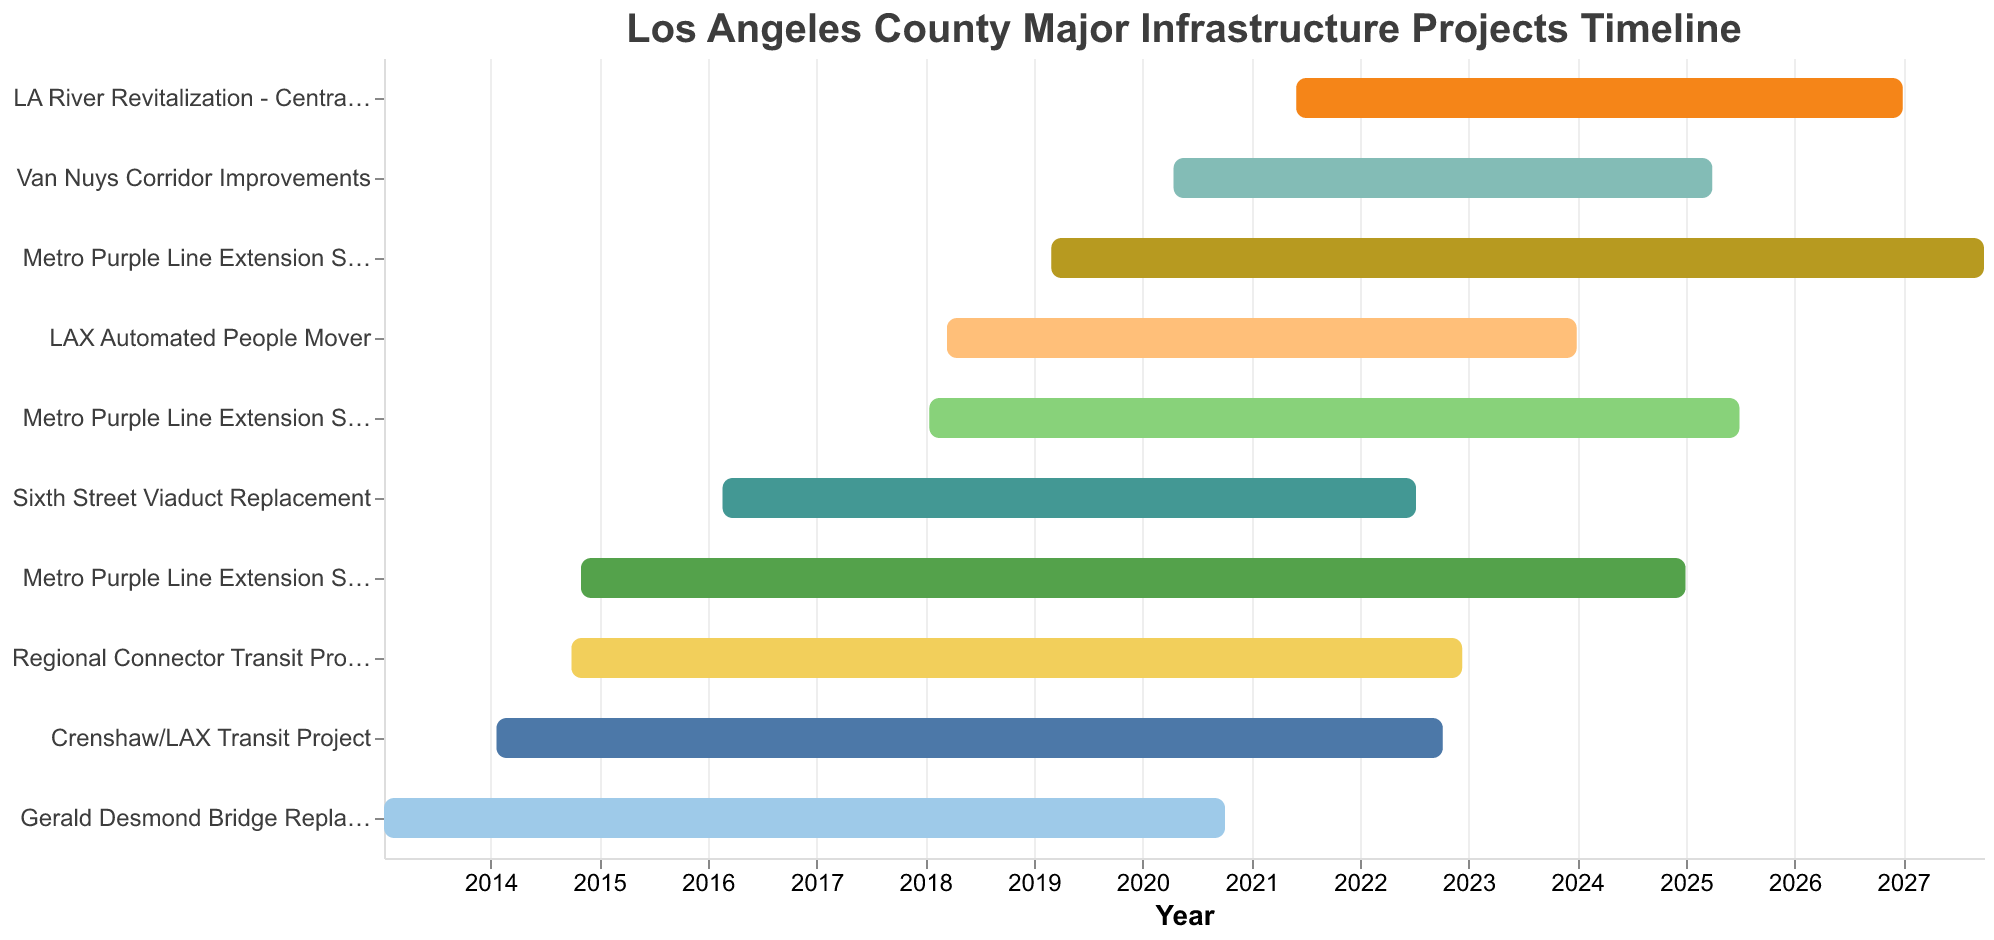What is the title of the figure? The title can be found at the top of the figure in a larger and more prominent font compared to other text elements.
Answer: Los Angeles County Major Infrastructure Projects Timeline Which project has the earliest start date? Examine the leftmost point on the horizontal axis to see which bar starts first. The project "Gerald Desmond Bridge Replacement" starts in early 2013.
Answer: Gerald Desmond Bridge Replacement When is the end date for the "Metro Purple Line Extension Section 3"? Find the bar labeled "Metro Purple Line Extension Section 3" and look at its endpoint on the horizontal axis.
Answer: September 30, 2027 Which project finishes the latest? Check all the endpoints of the bars and find the one that extends the furthest on the right side. The "Metro Purple Line Extension Section 3" ends the latest in September 2027.
Answer: Metro Purple Line Extension Section 3 How many projects started after 2015? Identify all the bars that begin after the year 2015 on the horizontal axis. Count these bars. The projects starting after 2015 are "Metro Purple Line Extension Section 2", "Metro Purple Line Extension Section 3", "LA River Revitalization - Central Valley", and "Van Nuys Corridor Improvements".
Answer: 4 Which project has the shortest duration? Calculate the durations for each project by subtracting the start date from the end date. The project with the shortest bar length is "Sixth Street Viaduct Replacement".
Answer: Sixth Street Viaduct Replacement What is the duration of the "Van Nuys Corridor Improvements" project? Calculate the duration by subtracting the start date from the end date. "Van Nuys Corridor Improvements" starts on April 15, 2020, and ends on March 31, 2025. Duration is the number of days between these dates.
Answer: About 5 years Which projects overlap in the year 2018? Identify the bars that span across the year 2018 by looking at their start and end points. The projects overlapping in 2018 are "Metro Purple Line Extension Section 1", "Metro Purple Line Extension Section 2", "Metro Purple Line Extension Section 3", "LAX Automated People Mover", "Sixth Street Viaduct Replacement", "Regional Connector Transit Project", and "Crenshaw/LAX Transit Project".
Answer: 7 For how long do the "Metro Purple Line Extension Section 2" and "LAX Automated People Mover" overlap? Find the overlapping section by comparing their timelines. "Metro Purple Line Extension Section 2" runs from January 15, 2018, to June 30, 2025, and "LAX Automated People Mover" from March 15, 2018, to December 31, 2023. They overlap from March 15, 2018, to December 31, 2023. Calculation: March 15, 2018 – December 31, 2023.
Answer: About 5 years and 9 months Which three projects have the longest durations, and what are those durations? Calculate the duration for each project and identify the three with the longest spans. The longest durations are for "Metro Purple Line Extension Section 3" (March 1, 2019 - September 30, 2027), "Metro Purple Line Extension Section 1" (November 1, 2014 - December 31, 2024), and "Metro Purple Line Extension Section 2" (January 15, 2018 - June 30, 2025). Their durations are approximately: Metro Purple Line Extension Section 3 (~8.6 years), Metro Purple Line Extension Section 1 (~10.1 years), Metro Purple Line Extension Section 2 (~7.5 years).
Answer: Metro Purple Line Extension Section 1 (~10.1 years), Metro Purple Line Extension Section 3 (~8.6 years), Metro Purple Line Extension Section 2 (~7.5 years) 